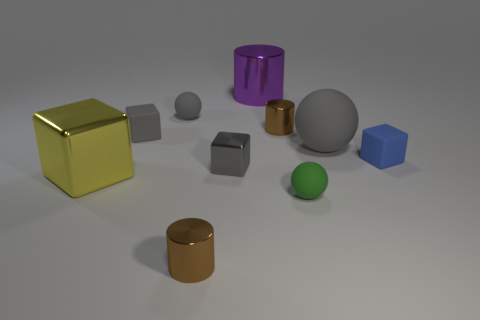What number of other objects are there of the same size as the yellow shiny thing?
Make the answer very short. 2. What size is the other shiny object that is the same shape as the yellow object?
Keep it short and to the point. Small. What shape is the small green rubber object that is right of the large purple metallic thing?
Your response must be concise. Sphere. Does the yellow metallic object have the same shape as the small gray rubber thing that is behind the tiny gray matte cube?
Provide a succinct answer. No. Are there the same number of blue objects that are left of the small blue matte thing and small blue blocks to the right of the big purple metal thing?
Your answer should be compact. No. What shape is the tiny shiny object that is the same color as the big rubber sphere?
Ensure brevity in your answer.  Cube. There is a metal object that is in front of the yellow block; does it have the same color as the small cylinder that is behind the yellow metallic thing?
Offer a terse response. Yes. Is the number of small cubes to the right of the small metallic cube greater than the number of small purple cylinders?
Offer a very short reply. Yes. What material is the big cylinder?
Your answer should be very brief. Metal. There is a big object that is made of the same material as the large cylinder; what is its shape?
Ensure brevity in your answer.  Cube. 